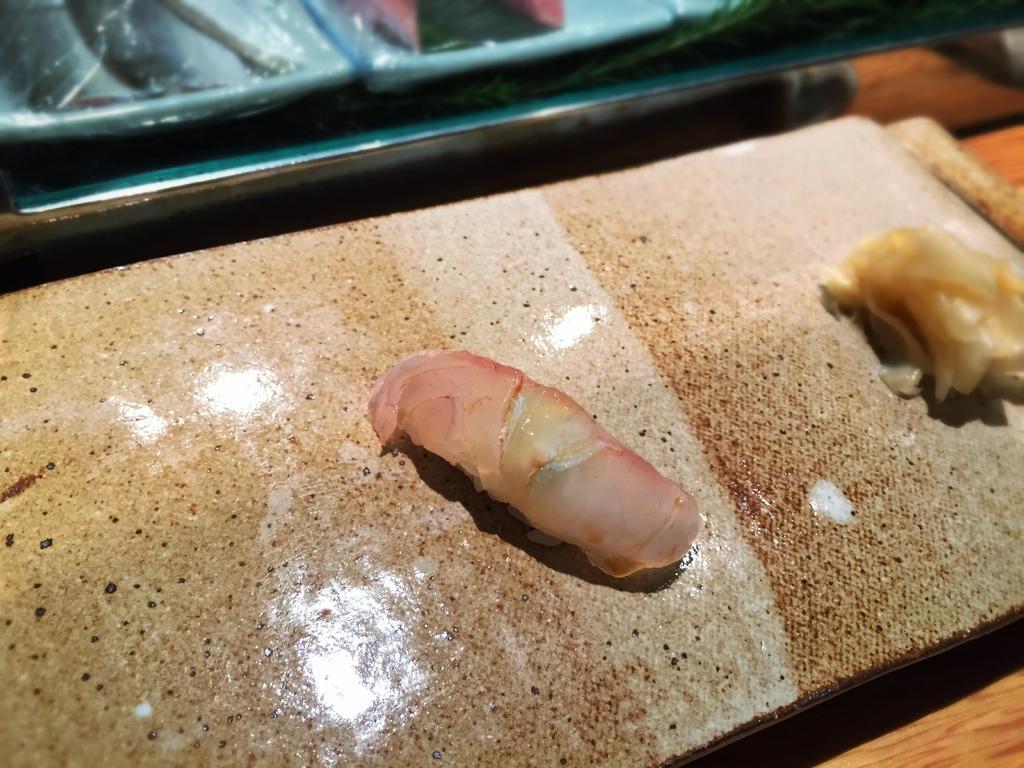Describe this image in one or two sentences. Here we can see two pieces of meat on a wooden board on a platform and beside to it there is a plate with something in it. 